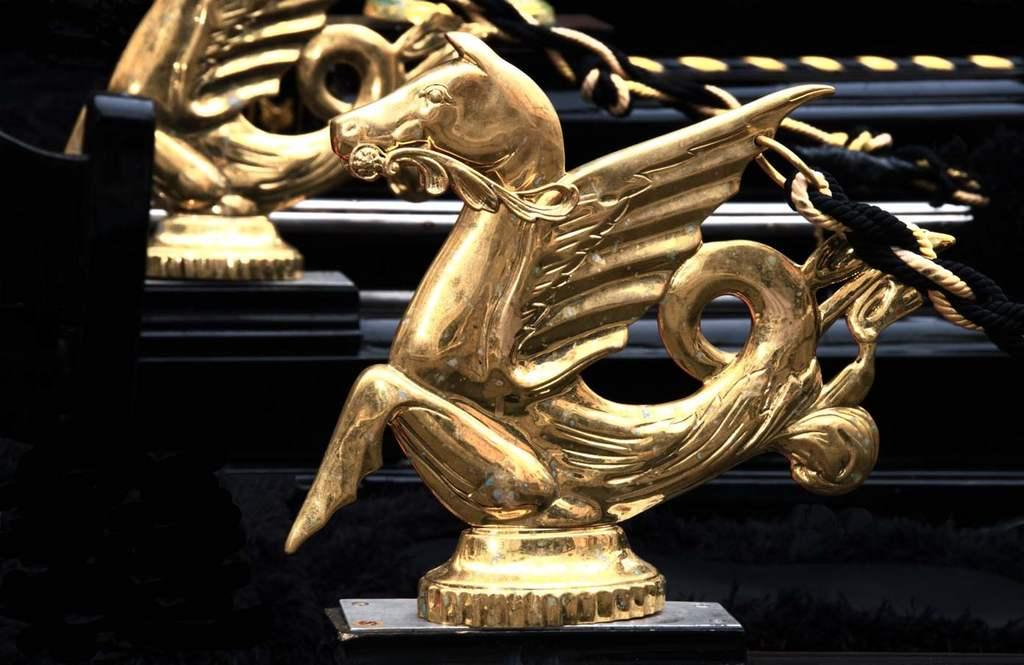What can be found in the left corner of the image? There is an object in the left corner of the image. What is located in the right corner of the image? There are ropes in the right corner of the image. What is situated in the foreground of the image? There are statues in the foreground of the image. Can you tell me how many boys are present in the image? There is no boy present in the image; the facts only mention an object, ropes, and statues. What type of army is depicted in the image? There is no army depicted in the image; the facts only mention an object, ropes, and statues. 